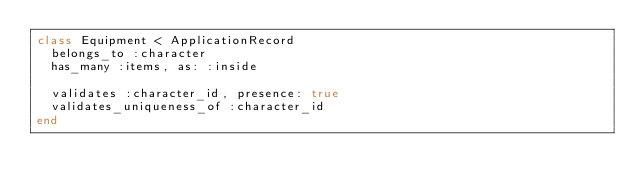<code> <loc_0><loc_0><loc_500><loc_500><_Ruby_>class Equipment < ApplicationRecord
  belongs_to :character
  has_many :items, as: :inside

  validates :character_id, presence: true
  validates_uniqueness_of :character_id
end
</code> 